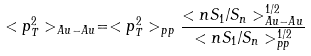Convert formula to latex. <formula><loc_0><loc_0><loc_500><loc_500>< p _ { T } ^ { 2 } > _ { A u - A u } = < p _ { T } ^ { 2 } > _ { p p } \frac { < n S _ { 1 } / S _ { n } > _ { A u - A u } ^ { 1 / 2 } } { < n S _ { 1 } / S _ { n } > _ { p p } ^ { 1 / 2 } }</formula> 